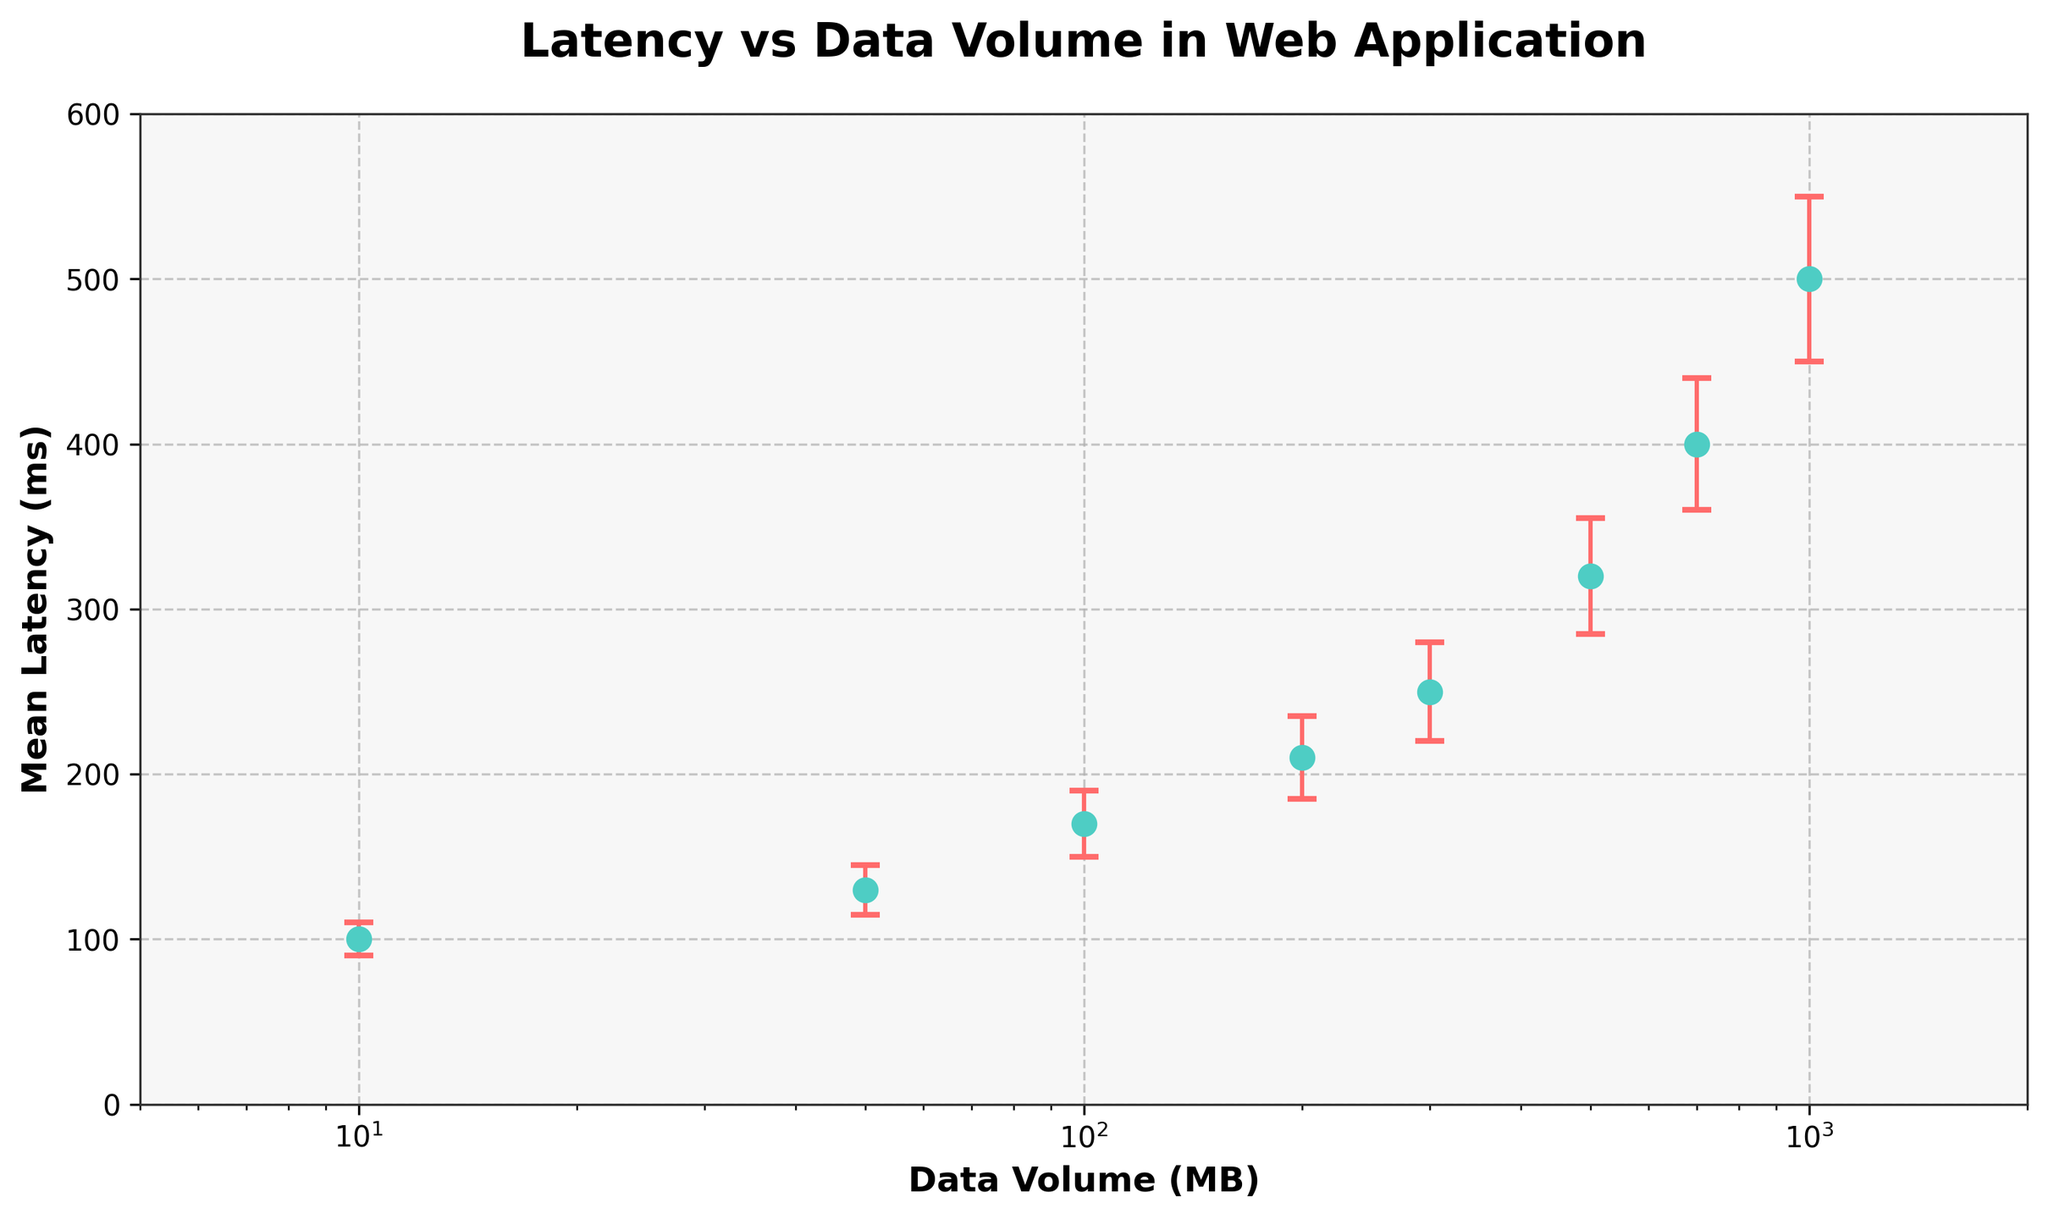What is the title of the plot? The title of the plot is shown at the top of the figure. In this case, the title reads "Latency vs Data Volume in Web Application".
Answer: Latency vs Data Volume in Web Application What is the x-axis of the plot labeled as? The label for the x-axis is located along the horizontal axis. Here, it is labeled as "Data Volume (MB)".
Answer: Data Volume (MB) How many data points are represented in the figure? Each data point is indicated by a marker (dot) on the plot. There are 8 markers visible on the plot.
Answer: 8 What is the mean latency when the data volume is 500 MB? To find this, locate the data point corresponding to 500 MB on the x-axis and then check its y-value. The mean latency here is 320 ms.
Answer: 320 ms What is the error range for the data volume of 1000 MB? Locate the data point for 1000 MB on the x-axis. The error bars extend above and below the point. The error is 50 ms, so the range is from 450 ms to 550 ms (500 - 50 and 500 + 50).
Answer: 450 ms to 550 ms Is the relationship between data volume and mean latency linear or non-linear? The plot shows a steady increase in mean latency with increasing data volume, but it is not a straight line, indicating a non-linear relationship.
Answer: Non-linear What is the difference in mean latency between 200 MB and 300 MB data volumes? Locate the mean latencies for 200 MB and 300 MB. These are 210 ms and 250 ms respectively. The difference is 250 ms - 210 ms = 40 ms.
Answer: 40 ms Does the mean latency for data volumes less than 100 MB fall below 150 ms? Check the mean latencies for data points with volumes of 10 MB, 50 MB, and 100 MB. The mean latencies are 100 ms, 130 ms, and 170 ms, respectively. Only the first two (10 MB, 50 MB) fall below 150 ms.
Answer: Yes, for 10 MB and 50 MB Which data volume has the highest mean latency? Identify the data point with the highest y-value (mean latency). The highest latency, 500 ms, occurs at 1000 MB.
Answer: 1000 MB For data volumes between 50 MB and 300 MB, how does the error in latency vary? Locate the data points for 50 MB, 100 MB, 200 MB, and 300 MB. The errors are 15 ms, 20 ms, 25 ms, and 30 ms respectively. Error increases with data volume.
Answer: Increases 